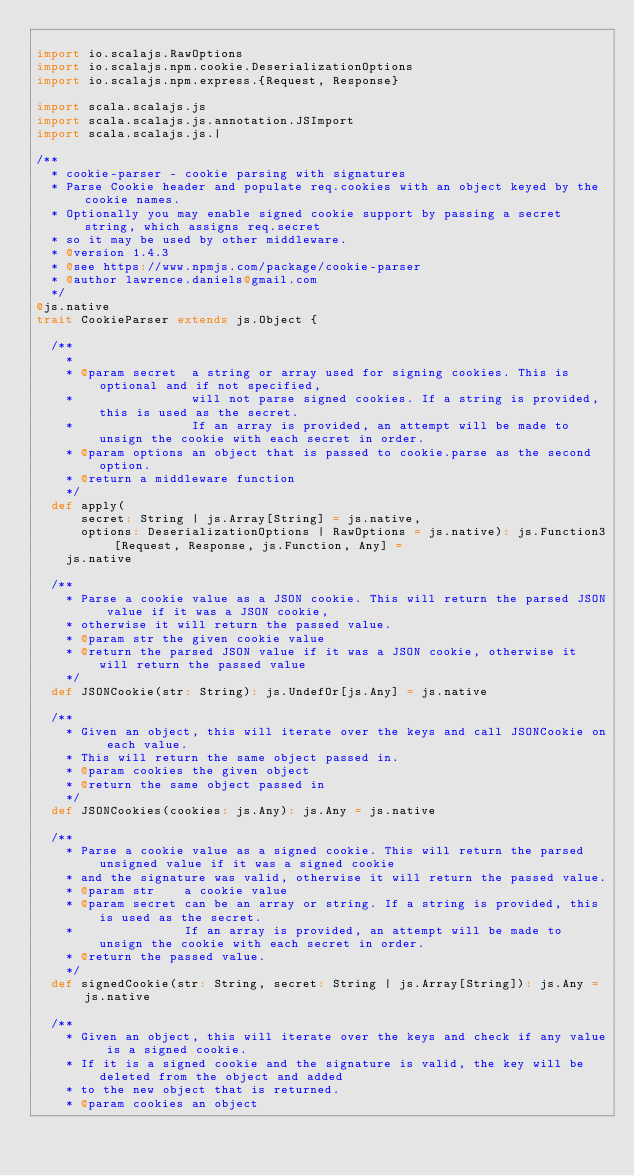Convert code to text. <code><loc_0><loc_0><loc_500><loc_500><_Scala_>
import io.scalajs.RawOptions
import io.scalajs.npm.cookie.DeserializationOptions
import io.scalajs.npm.express.{Request, Response}

import scala.scalajs.js
import scala.scalajs.js.annotation.JSImport
import scala.scalajs.js.|

/**
  * cookie-parser - cookie parsing with signatures
  * Parse Cookie header and populate req.cookies with an object keyed by the cookie names.
  * Optionally you may enable signed cookie support by passing a secret string, which assigns req.secret
  * so it may be used by other middleware.
  * @version 1.4.3
  * @see https://www.npmjs.com/package/cookie-parser
  * @author lawrence.daniels@gmail.com
  */
@js.native
trait CookieParser extends js.Object {

  /**
    *
    * @param secret  a string or array used for signing cookies. This is optional and if not specified,
    *                will not parse signed cookies. If a string is provided, this is used as the secret.
    *                If an array is provided, an attempt will be made to unsign the cookie with each secret in order.
    * @param options an object that is passed to cookie.parse as the second option.
    * @return a middleware function
    */
  def apply(
      secret: String | js.Array[String] = js.native,
      options: DeserializationOptions | RawOptions = js.native): js.Function3[Request, Response, js.Function, Any] =
    js.native

  /**
    * Parse a cookie value as a JSON cookie. This will return the parsed JSON value if it was a JSON cookie,
    * otherwise it will return the passed value.
    * @param str the given cookie value
    * @return the parsed JSON value if it was a JSON cookie, otherwise it will return the passed value
    */
  def JSONCookie(str: String): js.UndefOr[js.Any] = js.native

  /**
    * Given an object, this will iterate over the keys and call JSONCookie on each value.
    * This will return the same object passed in.
    * @param cookies the given object
    * @return the same object passed in
    */
  def JSONCookies(cookies: js.Any): js.Any = js.native

  /**
    * Parse a cookie value as a signed cookie. This will return the parsed unsigned value if it was a signed cookie
    * and the signature was valid, otherwise it will return the passed value.
    * @param str    a cookie value
    * @param secret can be an array or string. If a string is provided, this is used as the secret.
    *               If an array is provided, an attempt will be made to unsign the cookie with each secret in order.
    * @return the passed value.
    */
  def signedCookie(str: String, secret: String | js.Array[String]): js.Any = js.native

  /**
    * Given an object, this will iterate over the keys and check if any value is a signed cookie.
    * If it is a signed cookie and the signature is valid, the key will be deleted from the object and added
    * to the new object that is returned.
    * @param cookies an object</code> 